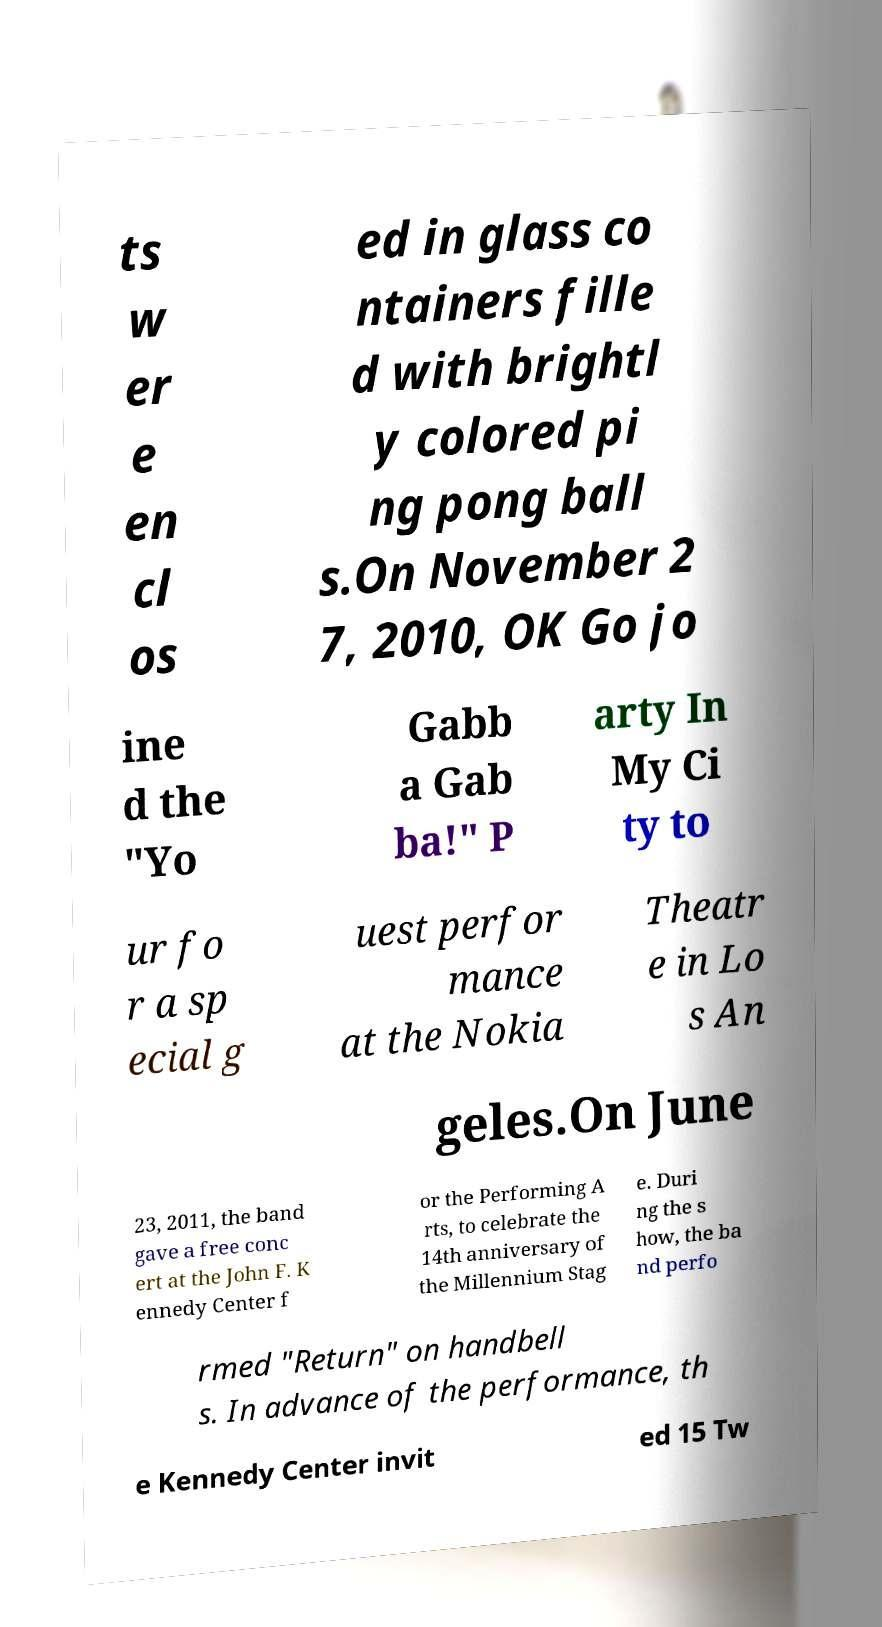Can you accurately transcribe the text from the provided image for me? ts w er e en cl os ed in glass co ntainers fille d with brightl y colored pi ng pong ball s.On November 2 7, 2010, OK Go jo ine d the "Yo Gabb a Gab ba!" P arty In My Ci ty to ur fo r a sp ecial g uest perfor mance at the Nokia Theatr e in Lo s An geles.On June 23, 2011, the band gave a free conc ert at the John F. K ennedy Center f or the Performing A rts, to celebrate the 14th anniversary of the Millennium Stag e. Duri ng the s how, the ba nd perfo rmed "Return" on handbell s. In advance of the performance, th e Kennedy Center invit ed 15 Tw 